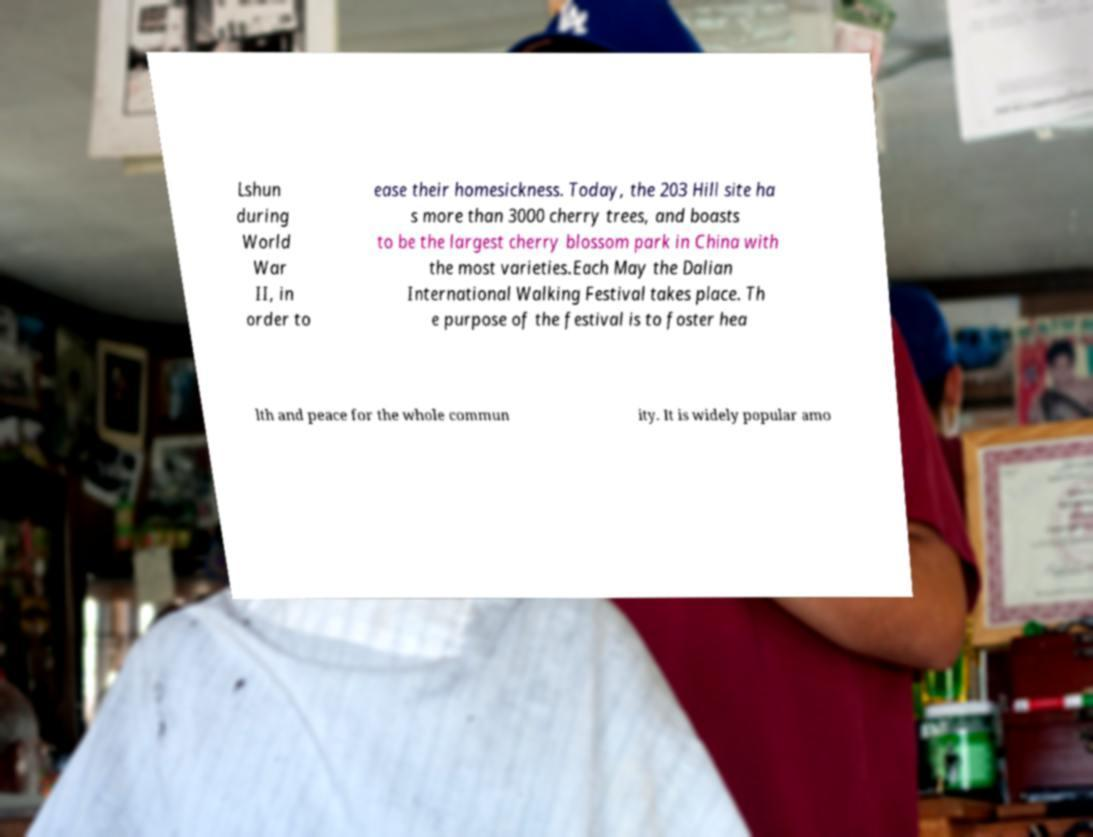Can you read and provide the text displayed in the image?This photo seems to have some interesting text. Can you extract and type it out for me? Lshun during World War II, in order to ease their homesickness. Today, the 203 Hill site ha s more than 3000 cherry trees, and boasts to be the largest cherry blossom park in China with the most varieties.Each May the Dalian International Walking Festival takes place. Th e purpose of the festival is to foster hea lth and peace for the whole commun ity. It is widely popular amo 